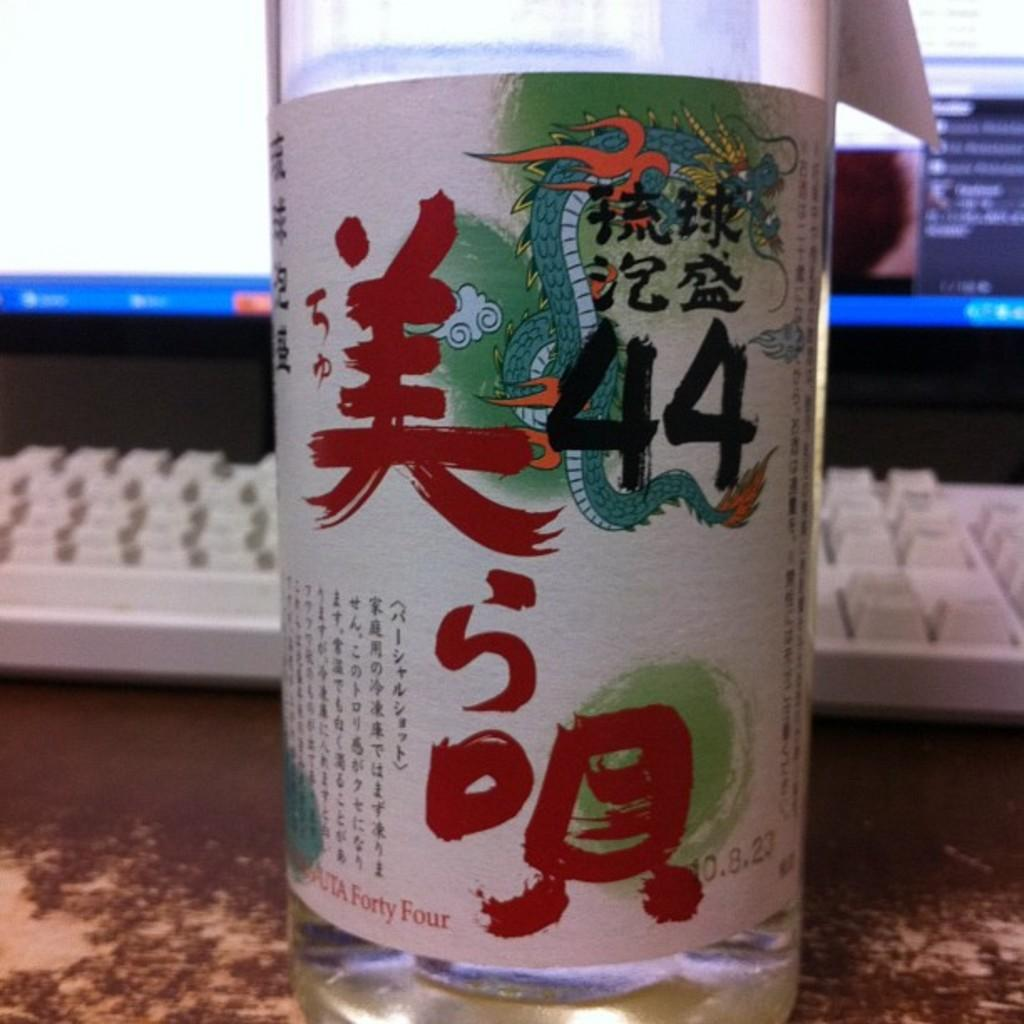<image>
Summarize the visual content of the image. A glass written in japanese with fourty four noted of importance in front of a computer keyboard. 